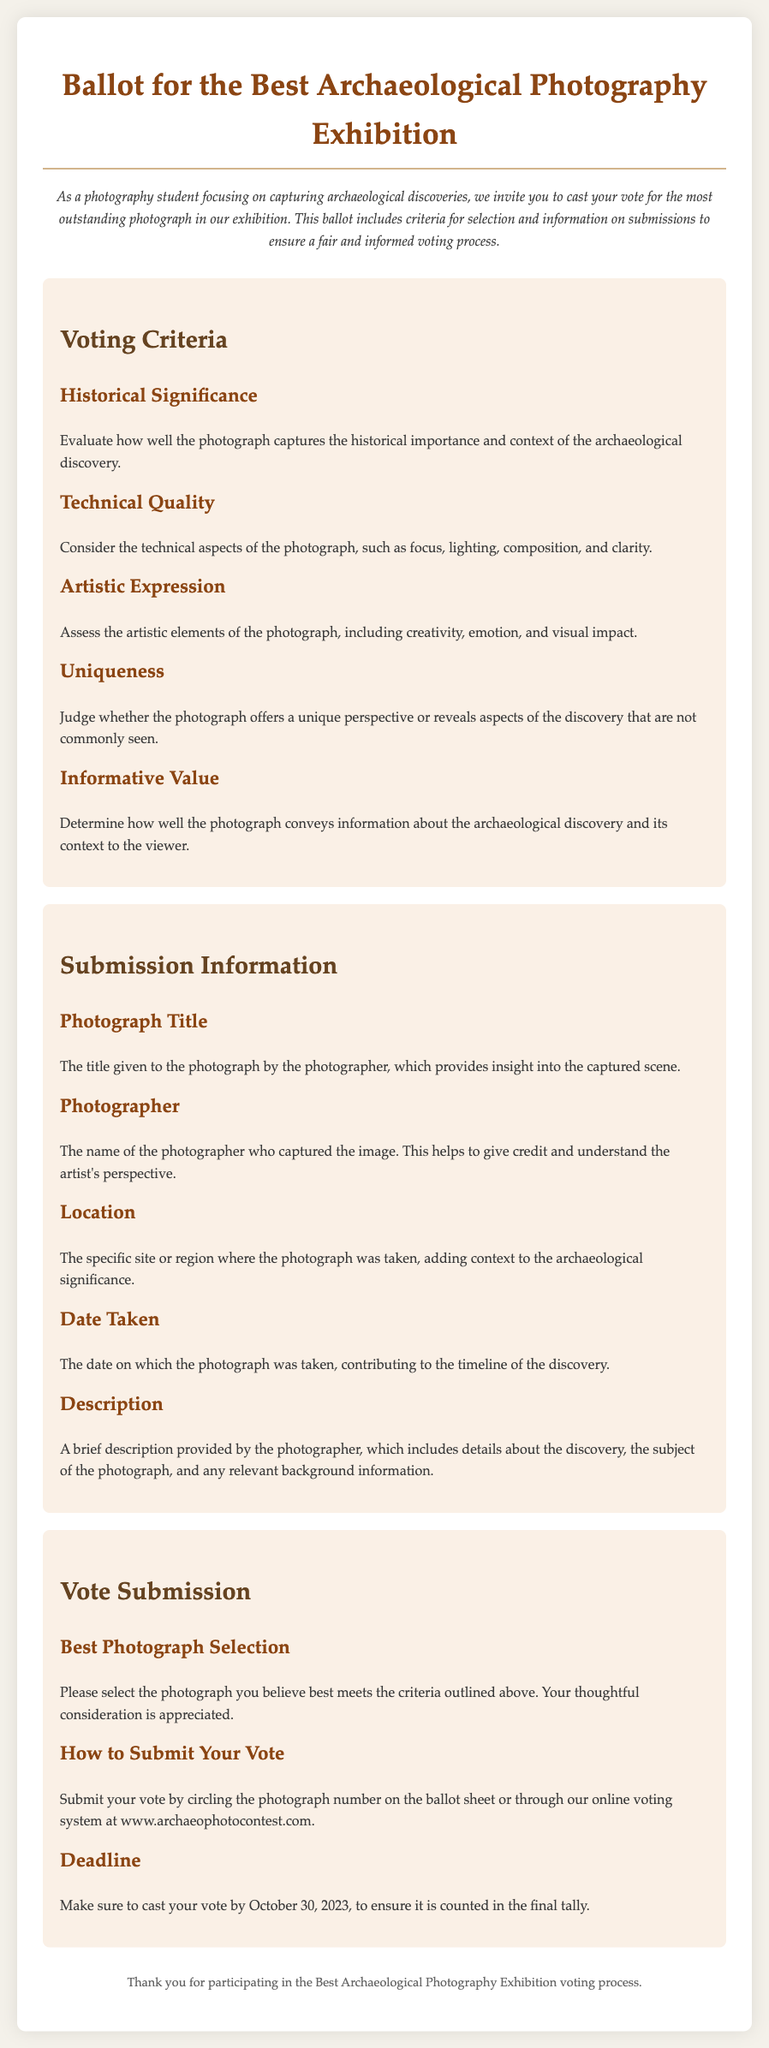What is the title of the document? The title of the document is displayed at the top of the page as the main heading.
Answer: Ballot for the Best Archaeological Photography Exhibition What is the deadline for submitting votes? The deadline is provided in the Vote Submission section, indicating when votes must be cast.
Answer: October 30, 2023 Who should be credited for the photographs? The document specifies that the name of the photographer should be included for credit.
Answer: Photographer What aspect does "Technical Quality" refer to in the criteria? This refers to the technical aspects of the photograph, as defined in the Voting Criteria section.
Answer: Focus, lighting, composition, and clarity How can participants submit their votes? The document describes the method for vote submission in the Vote Submission section.
Answer: Circle the photograph number or online voting What does "Informative Value" mean in the voting criteria? This section describes how the photograph conveys information about the archaeological discovery.
Answer: Conveys information about the archaeological discovery What is included in the "Description" of each photograph? The Description provides details about the discovery, the subject, and relevant background information.
Answer: Details about the discovery How many criteria are listed for voting? The number of criteria can be counted in the Voting Criteria section to determine how many are present.
Answer: Five What is the background color of the document? The background color is specified in the CSS styling of the document.
Answer: #f4f1ea 